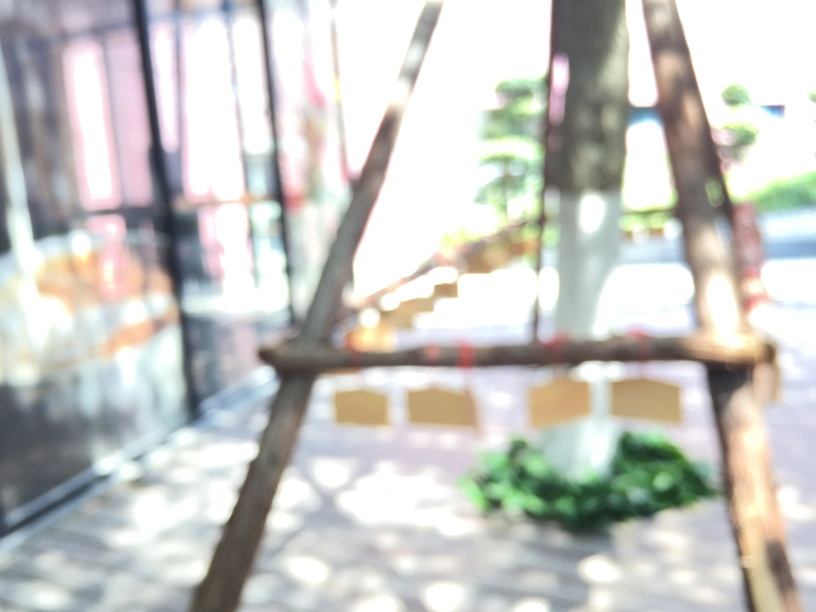Can you describe the environment shown in this image despite the blur? Although the details are obscured by the blur, we can infer a few things. There's abundant natural light suggesting an outdoor or a well-lit indoor space, potentially with greenery given the color tones at the bottom. Is there anything that might suggest the time of day? The brightness and the light's quality may hint at daytime, possibly morning or afternoon, but it's not possible to determine this precisely from the image. 